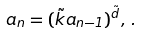<formula> <loc_0><loc_0><loc_500><loc_500>a _ { n } = ( \tilde { k } a _ { n - 1 } ) ^ { \tilde { d } } , \, .</formula> 